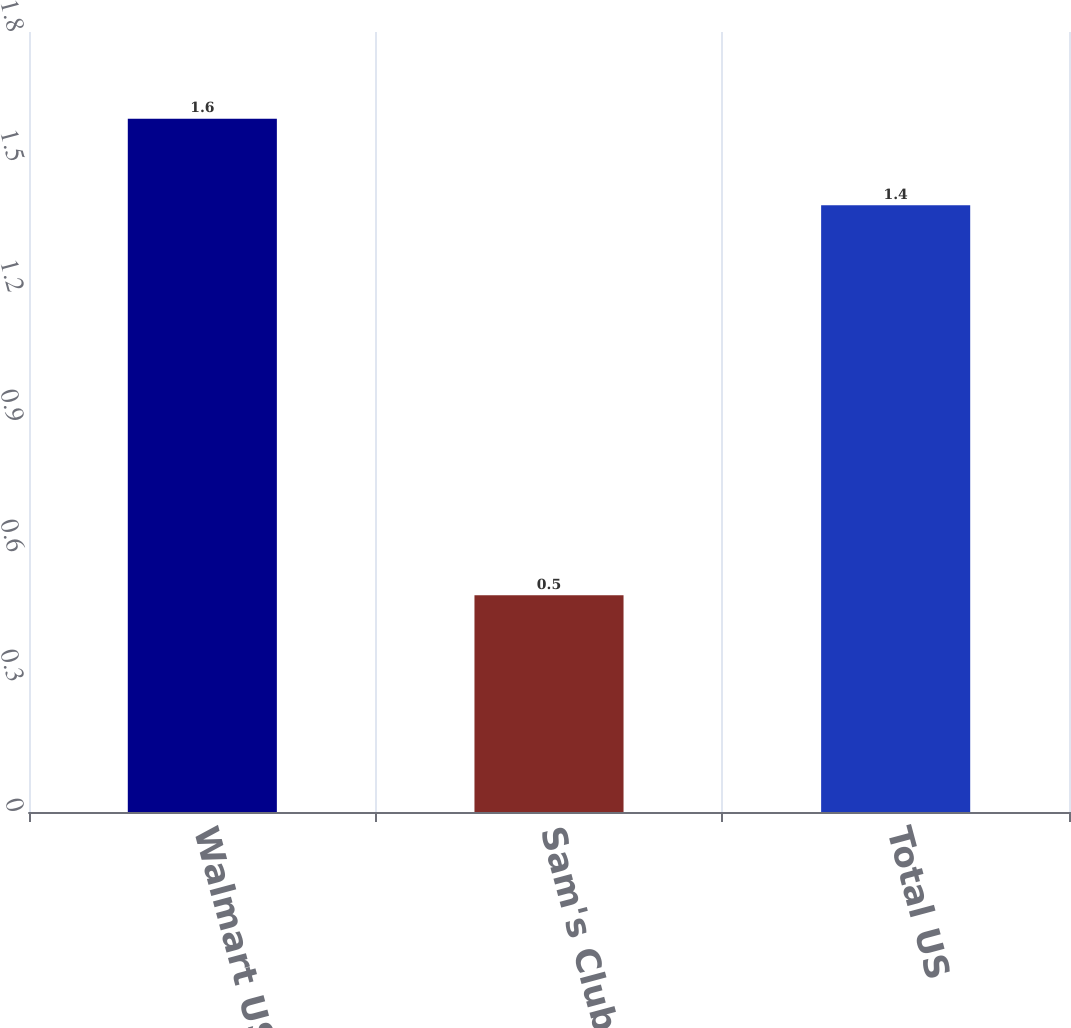<chart> <loc_0><loc_0><loc_500><loc_500><bar_chart><fcel>Walmart US<fcel>Sam's Club<fcel>Total US<nl><fcel>1.6<fcel>0.5<fcel>1.4<nl></chart> 